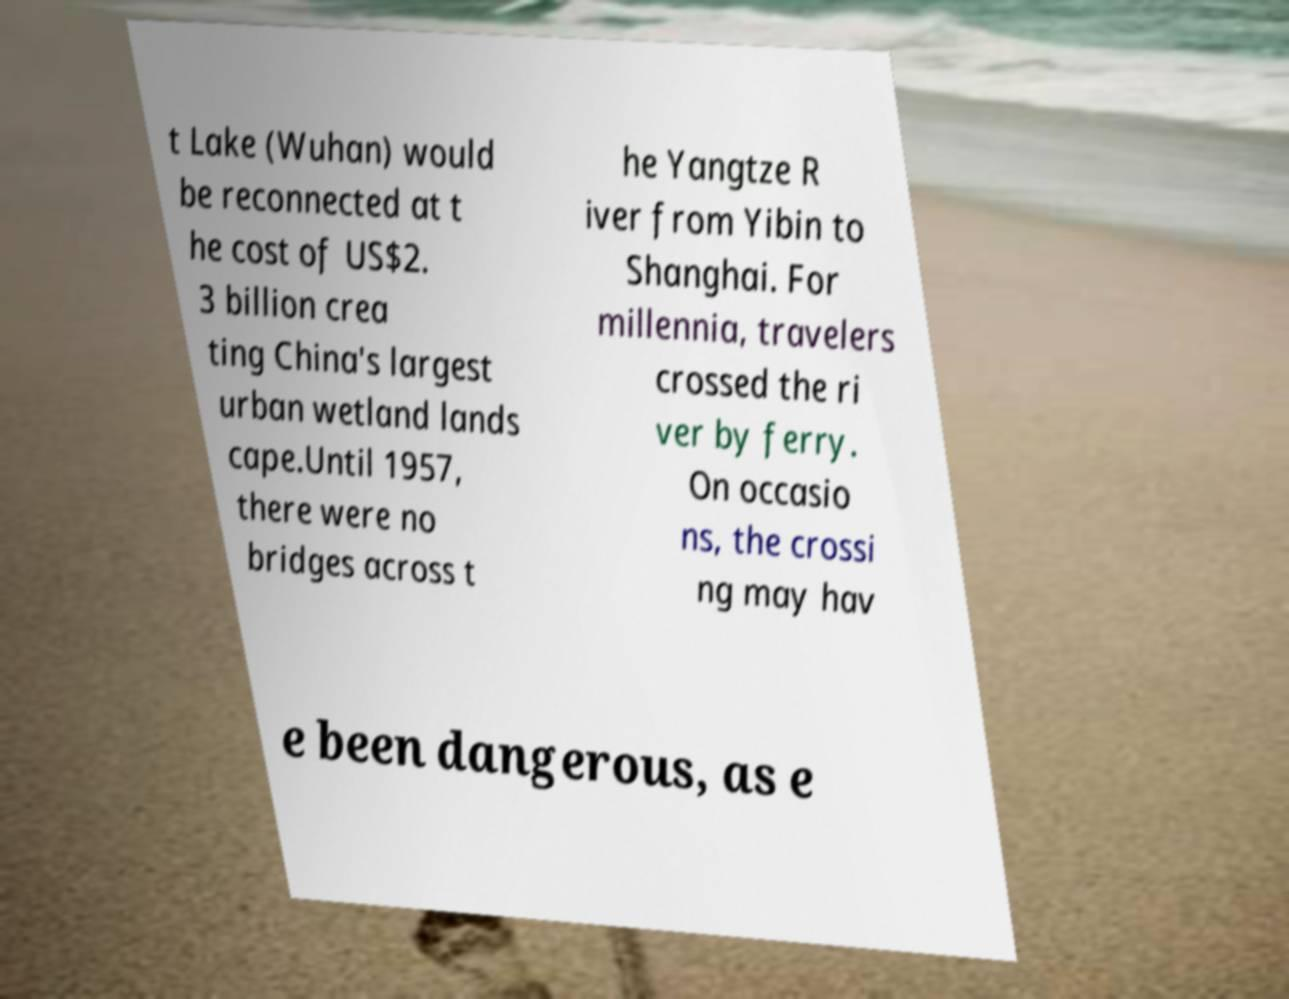For documentation purposes, I need the text within this image transcribed. Could you provide that? t Lake (Wuhan) would be reconnected at t he cost of US$2. 3 billion crea ting China's largest urban wetland lands cape.Until 1957, there were no bridges across t he Yangtze R iver from Yibin to Shanghai. For millennia, travelers crossed the ri ver by ferry. On occasio ns, the crossi ng may hav e been dangerous, as e 